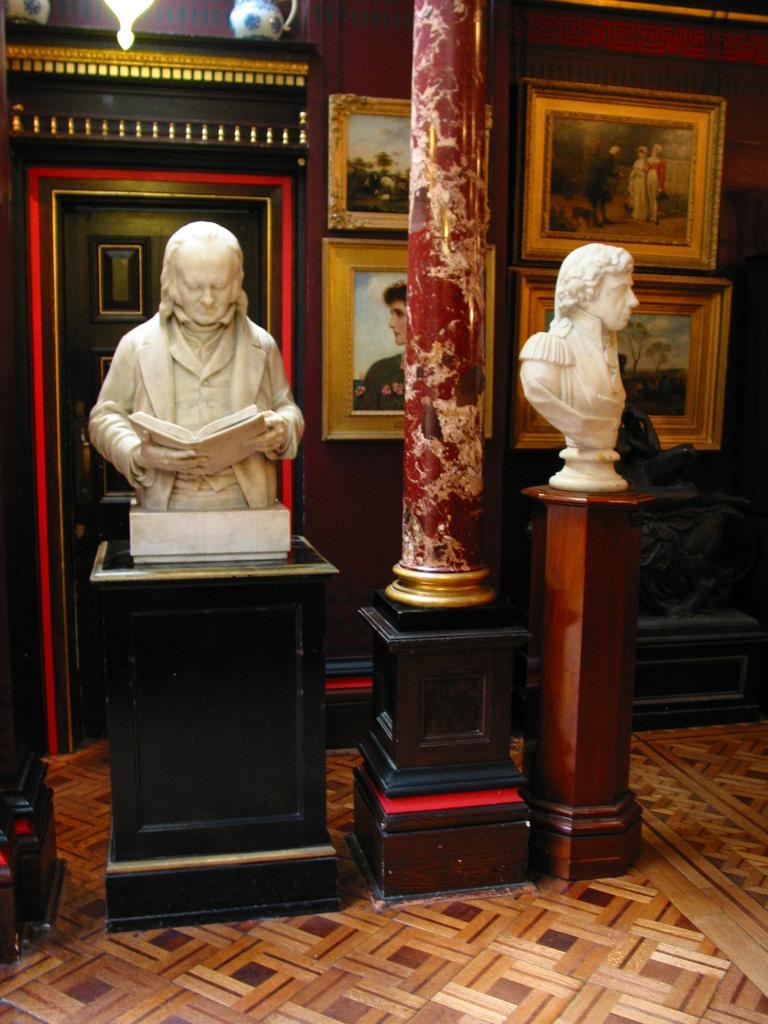How would you summarize this image in a sentence or two? This image is taken indoors. At the bottom of the image there is a floor. In the background there is a wall with carvings and picture frames on it. There is a door. In the middle of the image there is a pillar. There are two sculptures of a man holding a book in his hands. 